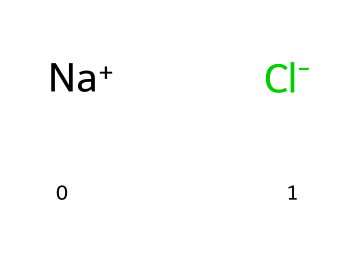What are the components of this chemical structure? The chemical structure contains sodium (Na) and chloride (Cl) ions. The SMILES representation shows [Na+] for sodium and [Cl-] for chloride, meaning it consists of these two distinct components.
Answer: sodium and chloride How many atoms are present in this molecule? The chemical structure consists of two types of ions, sodium and chloride. Each type contributes one atom, resulting in a total of two atoms in the molecule.
Answer: 2 What type of bonds are present in sodium chloride? Sodium chloride is formed through ionic bonding, where sodium donates an electron to chloride, resulting in the attraction between the positively charged sodium ion and the negatively charged chloride ion.
Answer: ionic Why is sodium chloride classified as an electrolyte? Sodium chloride dissociates into its ions (Na+ and Cl-) in solution, allowing it to conduct electricity, which is a defining characteristic of electrolytes.
Answer: conducts electricity What is the charge of the sodium ion in this structure? The SMILES notation shows [Na+], which indicates that the sodium ion has a positive charge. This contributes to the ionic nature of the compound.
Answer: positive What characteristic property of sodium chloride makes it essential in traditional baseball park snacks? Sodium chloride is known for imparting a salty flavor, which is a desired taste in snacks like peanuts, popcorn, and pretzels at baseball parks.
Answer: salty flavor How many distinct ions are present in sodium chloride? The chemical structure indicates that there are two distinct ions: one sodium ion and one chloride ion. This accounts for the total ion diversity in the structure.
Answer: 2 